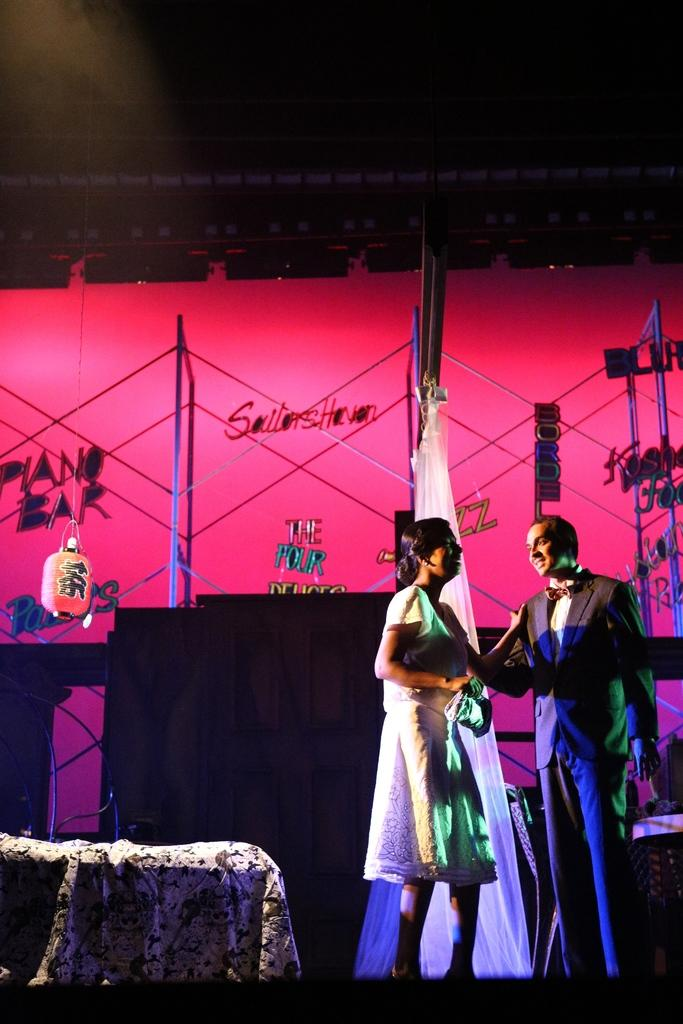How many people are in the image? There are two persons standing in the image. What is the person on the left wearing? The person on the left is wearing a white dress. What can be seen in the background of the image? There are poles, lights, and other objects in the background of the image. Can you hear the cattle sneezing in the background of the image? There is no mention of cattle or sneezing in the image, so it cannot be heard or seen. 